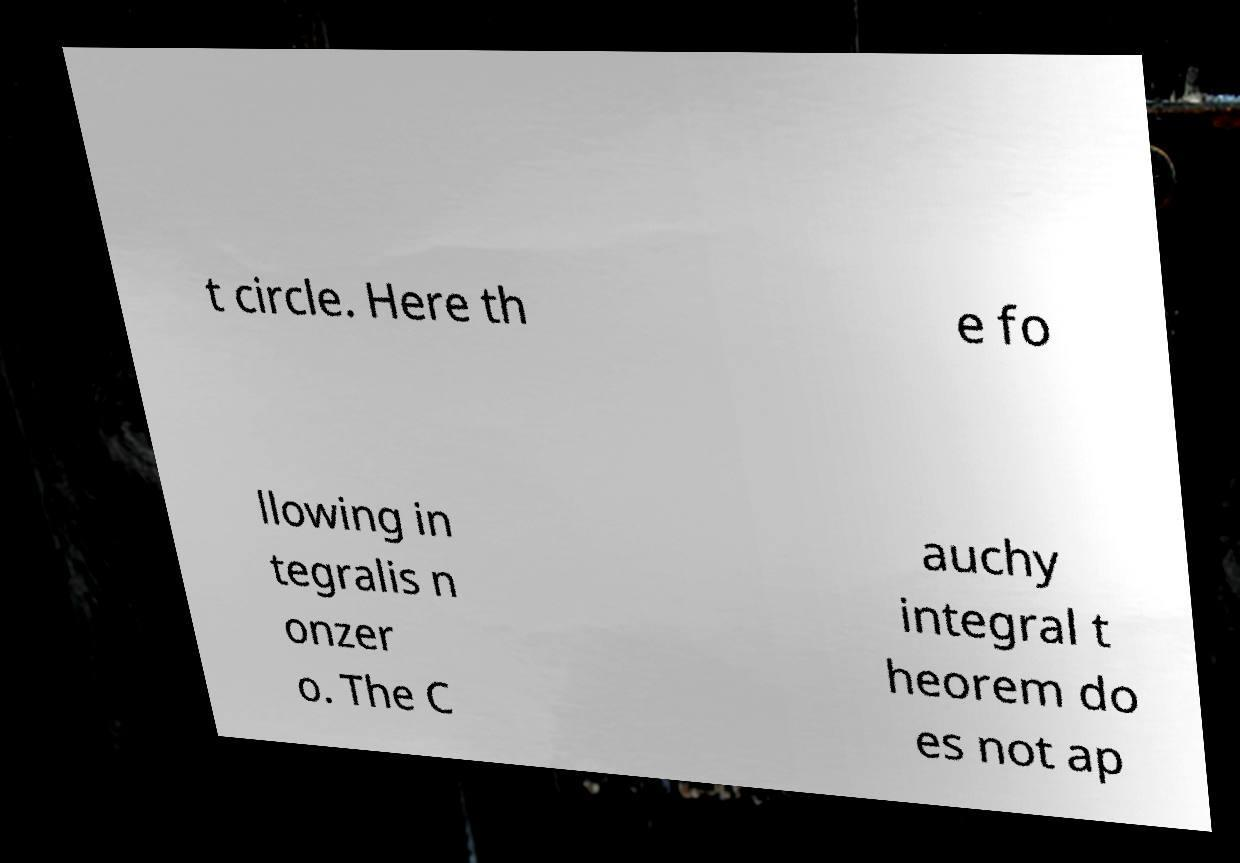I need the written content from this picture converted into text. Can you do that? t circle. Here th e fo llowing in tegralis n onzer o. The C auchy integral t heorem do es not ap 